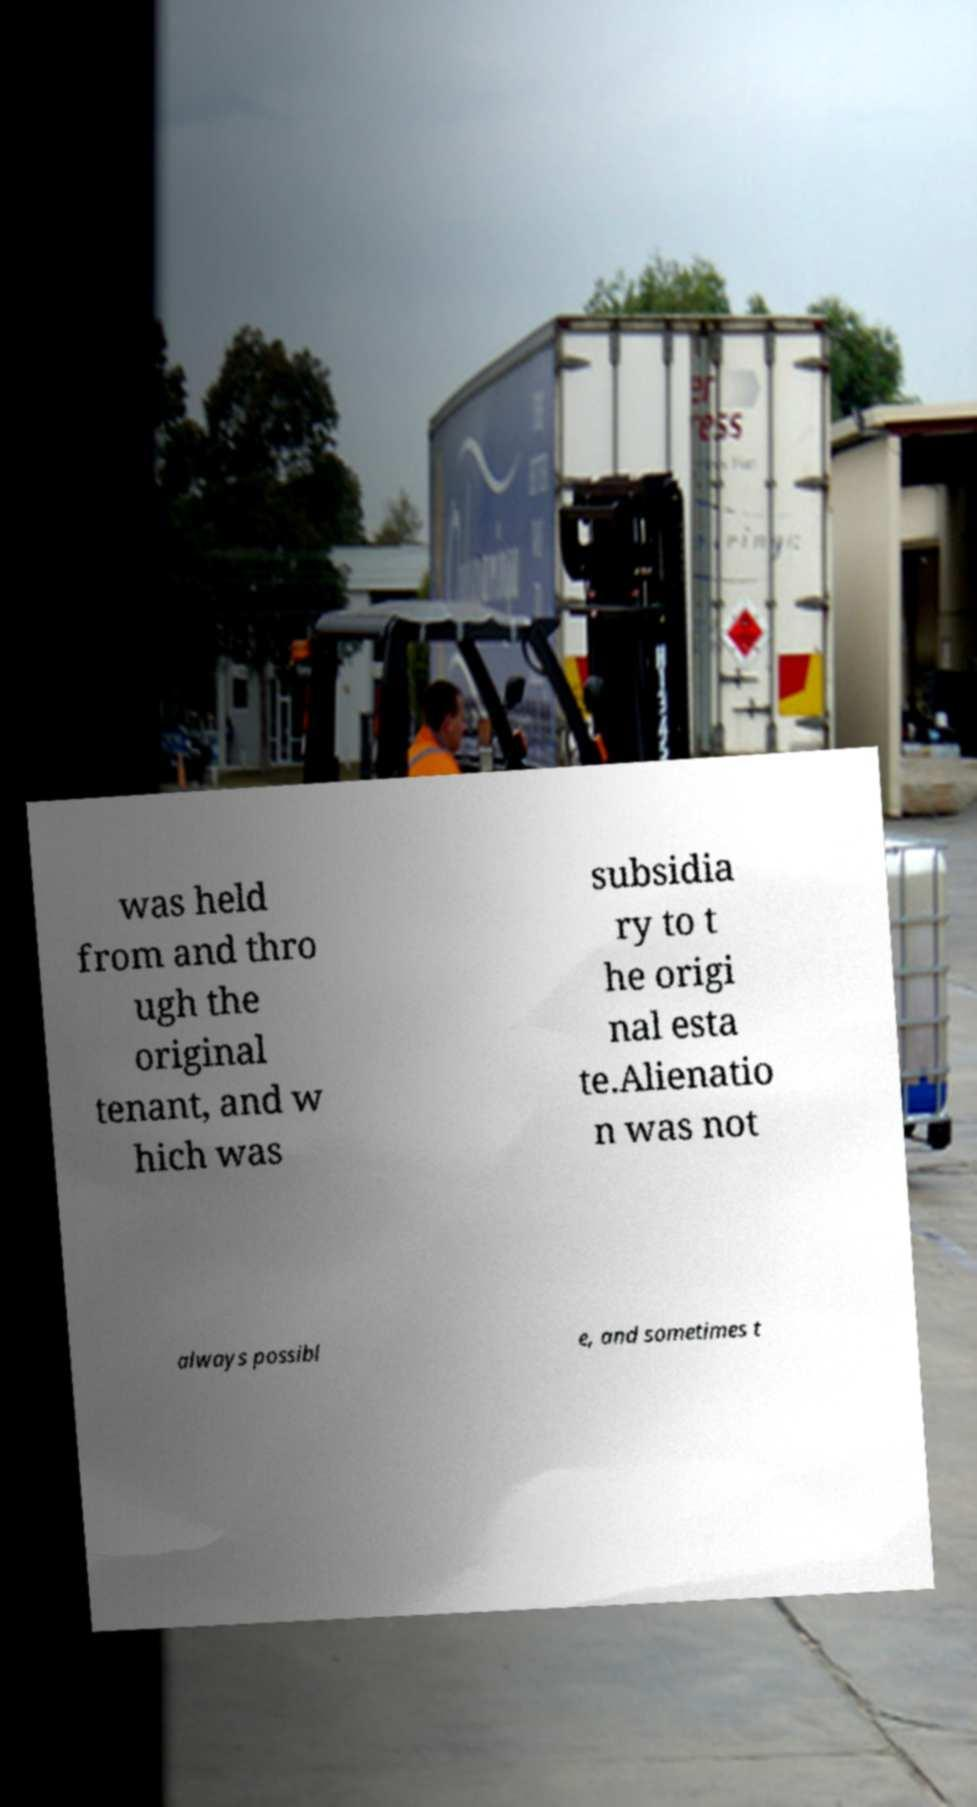Could you extract and type out the text from this image? was held from and thro ugh the original tenant, and w hich was subsidia ry to t he origi nal esta te.Alienatio n was not always possibl e, and sometimes t 